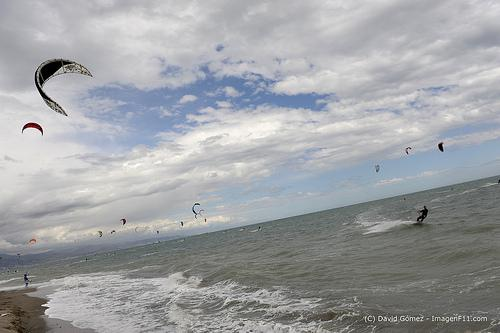Question: what is blue?
Choices:
A. Shirt.
B. Jeans.
C. Eyes.
D. Sky.
Answer with the letter. Answer: D Question: what is white?
Choices:
A. Waves.
B. Uniform.
C. Paper.
D. Door.
Answer with the letter. Answer: A Question: where does the picture take place?
Choices:
A. Zoo.
B. At the beach.
C. Park.
D. Restaurant.
Answer with the letter. Answer: B 